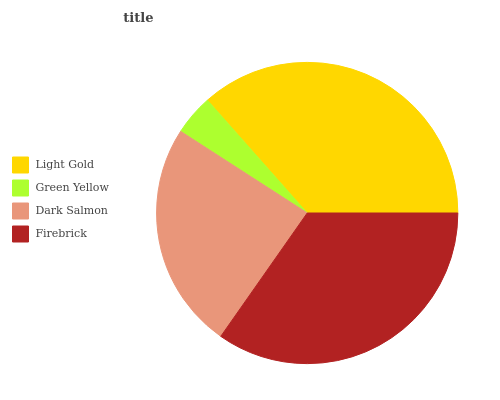Is Green Yellow the minimum?
Answer yes or no. Yes. Is Light Gold the maximum?
Answer yes or no. Yes. Is Dark Salmon the minimum?
Answer yes or no. No. Is Dark Salmon the maximum?
Answer yes or no. No. Is Dark Salmon greater than Green Yellow?
Answer yes or no. Yes. Is Green Yellow less than Dark Salmon?
Answer yes or no. Yes. Is Green Yellow greater than Dark Salmon?
Answer yes or no. No. Is Dark Salmon less than Green Yellow?
Answer yes or no. No. Is Firebrick the high median?
Answer yes or no. Yes. Is Dark Salmon the low median?
Answer yes or no. Yes. Is Green Yellow the high median?
Answer yes or no. No. Is Light Gold the low median?
Answer yes or no. No. 